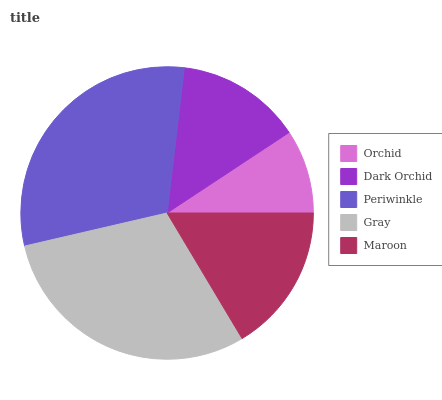Is Orchid the minimum?
Answer yes or no. Yes. Is Periwinkle the maximum?
Answer yes or no. Yes. Is Dark Orchid the minimum?
Answer yes or no. No. Is Dark Orchid the maximum?
Answer yes or no. No. Is Dark Orchid greater than Orchid?
Answer yes or no. Yes. Is Orchid less than Dark Orchid?
Answer yes or no. Yes. Is Orchid greater than Dark Orchid?
Answer yes or no. No. Is Dark Orchid less than Orchid?
Answer yes or no. No. Is Maroon the high median?
Answer yes or no. Yes. Is Maroon the low median?
Answer yes or no. Yes. Is Periwinkle the high median?
Answer yes or no. No. Is Dark Orchid the low median?
Answer yes or no. No. 